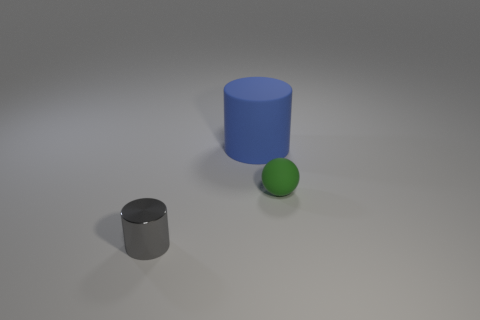Is there any other thing that has the same size as the blue cylinder?
Keep it short and to the point. No. Are there any other things that have the same material as the gray cylinder?
Your response must be concise. No. Is the number of tiny gray objects greater than the number of large yellow spheres?
Offer a terse response. Yes. Is there a cyan matte cube?
Make the answer very short. No. What shape is the tiny object that is on the right side of the thing that is in front of the green rubber sphere?
Give a very brief answer. Sphere. What number of objects are either green shiny balls or tiny objects that are on the left side of the big cylinder?
Provide a succinct answer. 1. There is a cylinder right of the cylinder in front of the rubber object that is behind the tiny ball; what is its color?
Keep it short and to the point. Blue. There is another gray object that is the same shape as the big matte object; what is its material?
Give a very brief answer. Metal. What color is the matte sphere?
Your response must be concise. Green. Is the metal object the same color as the tiny rubber sphere?
Give a very brief answer. No. 